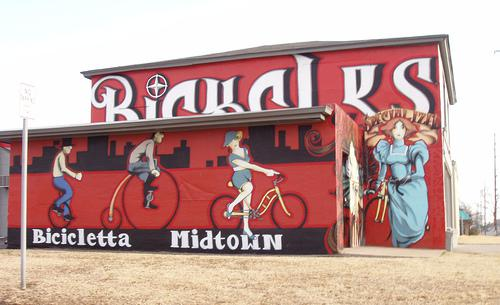Question: how many people are shown on the building?
Choices:
A. Three.
B. Five.
C. Four.
D. Six.
Answer with the letter. Answer: C Question: what type of weather is shown?
Choices:
A. Clear.
B. Cloudy.
C. Rainy.
D. Snowy.
Answer with the letter. Answer: A 